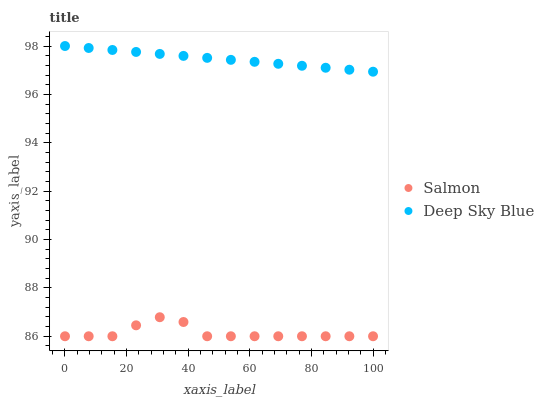Does Salmon have the minimum area under the curve?
Answer yes or no. Yes. Does Deep Sky Blue have the maximum area under the curve?
Answer yes or no. Yes. Does Deep Sky Blue have the minimum area under the curve?
Answer yes or no. No. Is Deep Sky Blue the smoothest?
Answer yes or no. Yes. Is Salmon the roughest?
Answer yes or no. Yes. Is Deep Sky Blue the roughest?
Answer yes or no. No. Does Salmon have the lowest value?
Answer yes or no. Yes. Does Deep Sky Blue have the lowest value?
Answer yes or no. No. Does Deep Sky Blue have the highest value?
Answer yes or no. Yes. Is Salmon less than Deep Sky Blue?
Answer yes or no. Yes. Is Deep Sky Blue greater than Salmon?
Answer yes or no. Yes. Does Salmon intersect Deep Sky Blue?
Answer yes or no. No. 